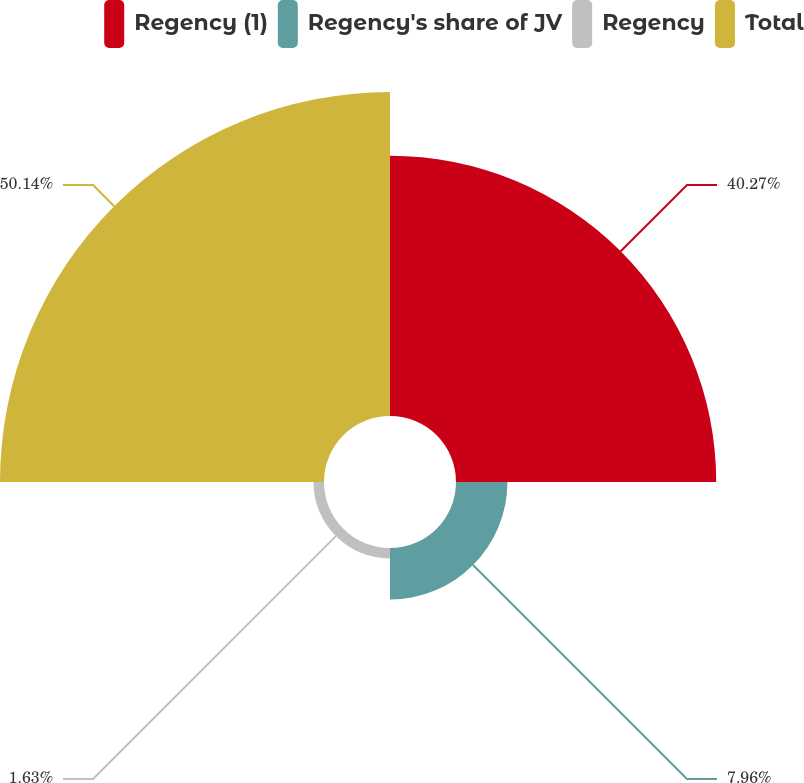<chart> <loc_0><loc_0><loc_500><loc_500><pie_chart><fcel>Regency (1)<fcel>Regency's share of JV<fcel>Regency<fcel>Total<nl><fcel>40.27%<fcel>7.96%<fcel>1.63%<fcel>50.14%<nl></chart> 